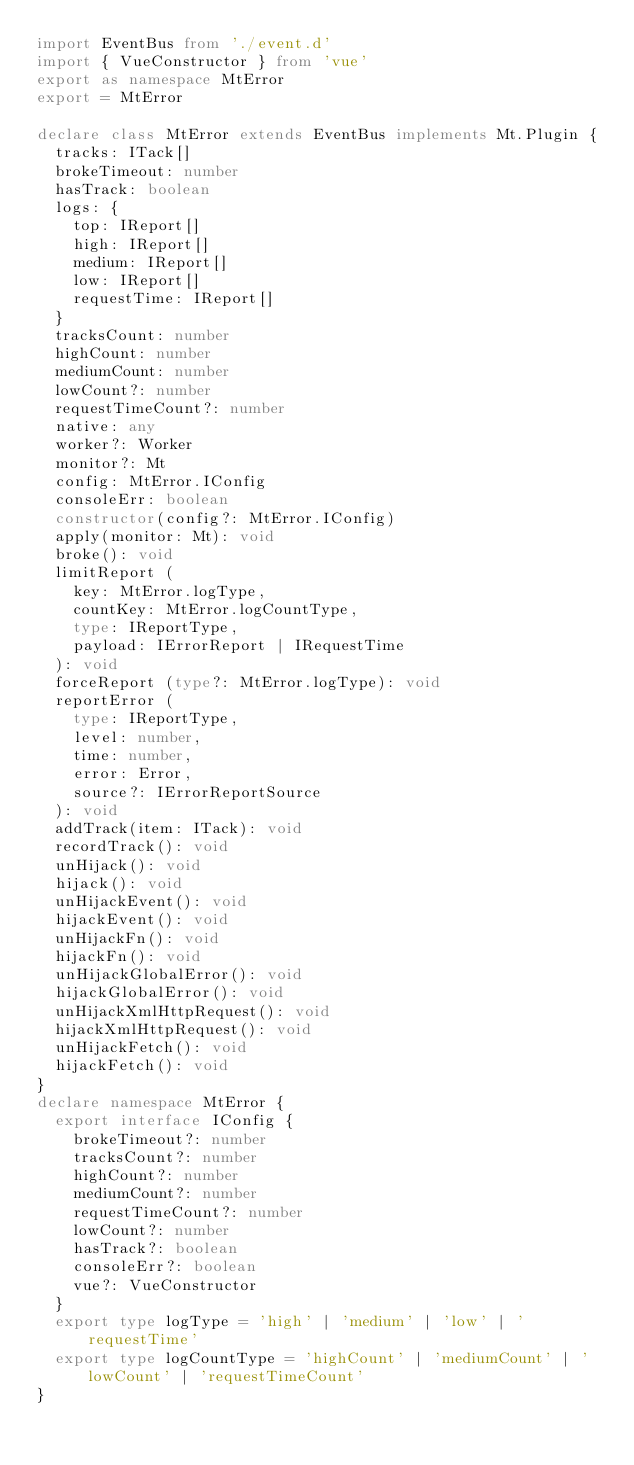<code> <loc_0><loc_0><loc_500><loc_500><_TypeScript_>import EventBus from './event.d'
import { VueConstructor } from 'vue'
export as namespace MtError
export = MtError

declare class MtError extends EventBus implements Mt.Plugin {
  tracks: ITack[]
  brokeTimeout: number
  hasTrack: boolean
  logs: {
    top: IReport[]
    high: IReport[]
    medium: IReport[]
    low: IReport[]
    requestTime: IReport[]
  }
  tracksCount: number
  highCount: number
  mediumCount: number
  lowCount?: number
  requestTimeCount?: number
  native: any
  worker?: Worker
  monitor?: Mt
  config: MtError.IConfig
  consoleErr: boolean
  constructor(config?: MtError.IConfig)
  apply(monitor: Mt): void
  broke(): void
  limitReport (
    key: MtError.logType,
    countKey: MtError.logCountType,
    type: IReportType,
    payload: IErrorReport | IRequestTime
  ): void 
  forceReport (type?: MtError.logType): void 
  reportError (
    type: IReportType,
    level: number,
    time: number,
    error: Error,
    source?: IErrorReportSource
  ): void
  addTrack(item: ITack): void
  recordTrack(): void
  unHijack(): void
  hijack(): void
  unHijackEvent(): void
  hijackEvent(): void
  unHijackFn(): void
  hijackFn(): void
  unHijackGlobalError(): void
  hijackGlobalError(): void
  unHijackXmlHttpRequest(): void
  hijackXmlHttpRequest(): void
  unHijackFetch(): void
  hijackFetch(): void
}
declare namespace MtError {
  export interface IConfig {
    brokeTimeout?: number
    tracksCount?: number
    highCount?: number
    mediumCount?: number
    requestTimeCount?: number
    lowCount?: number
    hasTrack?: boolean
    consoleErr?: boolean
    vue?: VueConstructor
  }
  export type logType = 'high' | 'medium' | 'low' | 'requestTime'
  export type logCountType = 'highCount' | 'mediumCount' | 'lowCount' | 'requestTimeCount'
}
</code> 